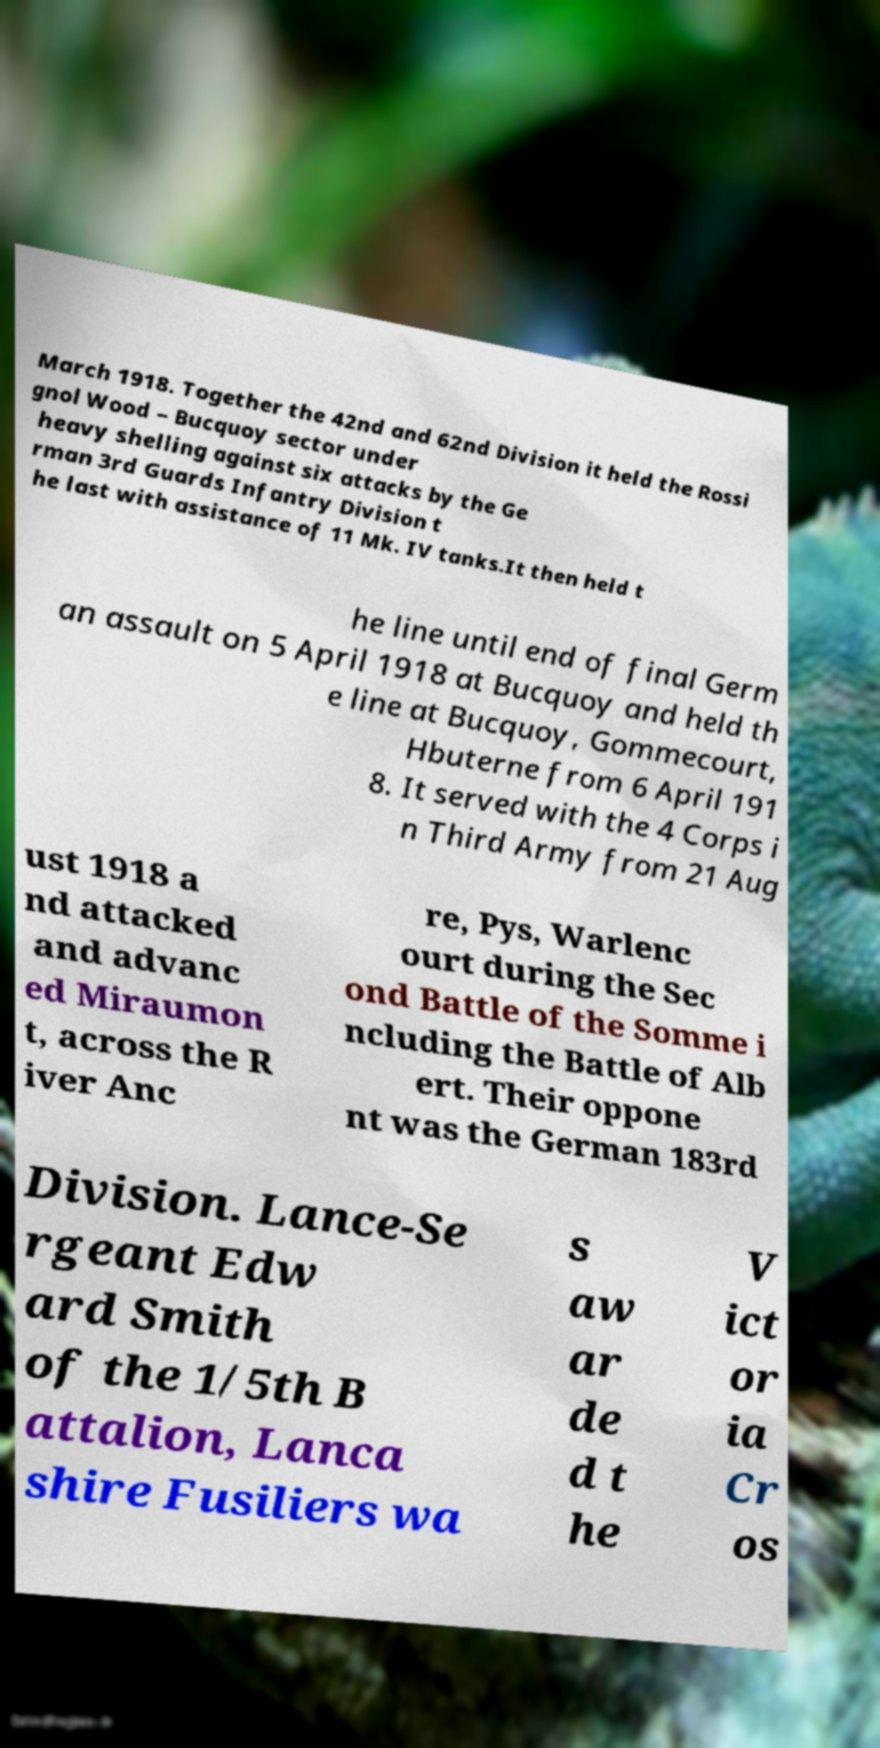For documentation purposes, I need the text within this image transcribed. Could you provide that? March 1918. Together the 42nd and 62nd Division it held the Rossi gnol Wood – Bucquoy sector under heavy shelling against six attacks by the Ge rman 3rd Guards Infantry Division t he last with assistance of 11 Mk. IV tanks.It then held t he line until end of final Germ an assault on 5 April 1918 at Bucquoy and held th e line at Bucquoy, Gommecourt, Hbuterne from 6 April 191 8. It served with the 4 Corps i n Third Army from 21 Aug ust 1918 a nd attacked and advanc ed Miraumon t, across the R iver Anc re, Pys, Warlenc ourt during the Sec ond Battle of the Somme i ncluding the Battle of Alb ert. Their oppone nt was the German 183rd Division. Lance-Se rgeant Edw ard Smith of the 1/5th B attalion, Lanca shire Fusiliers wa s aw ar de d t he V ict or ia Cr os 